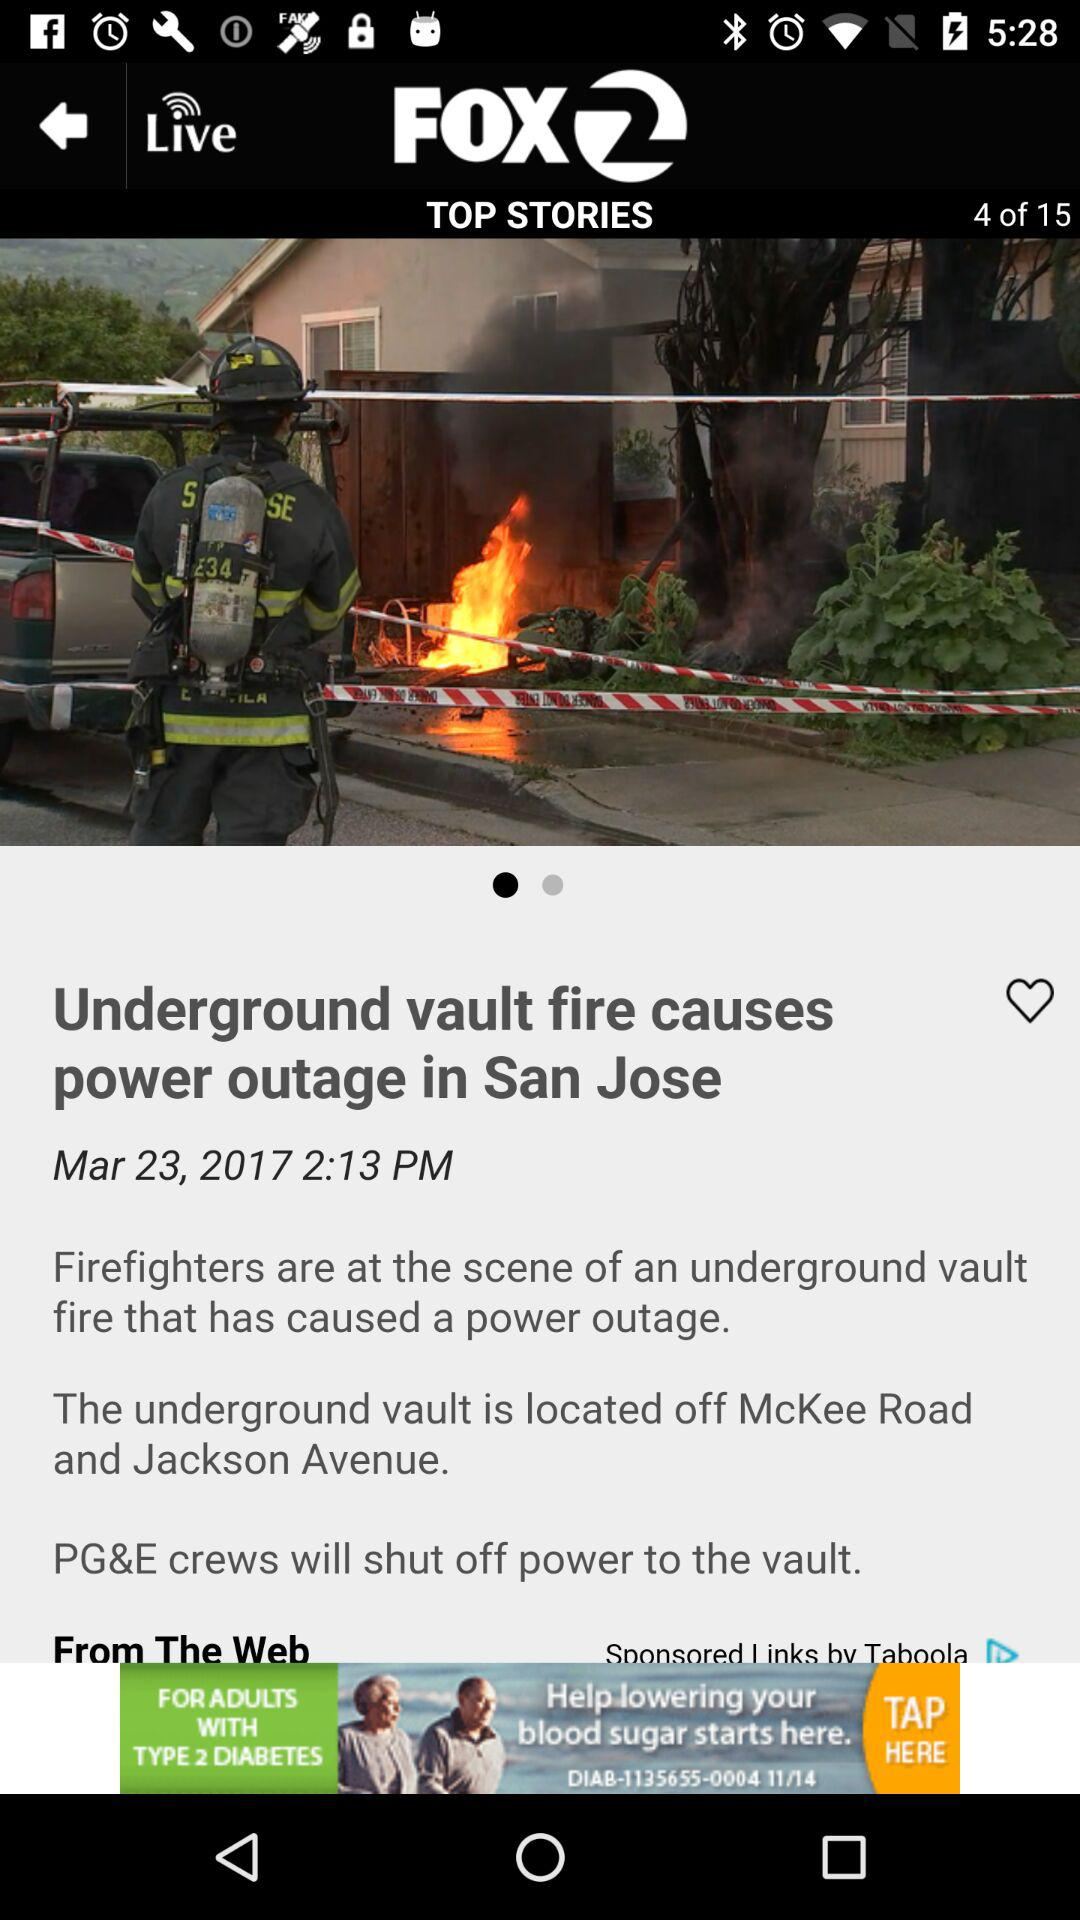What is the application name? The application name is "FOX 2". 